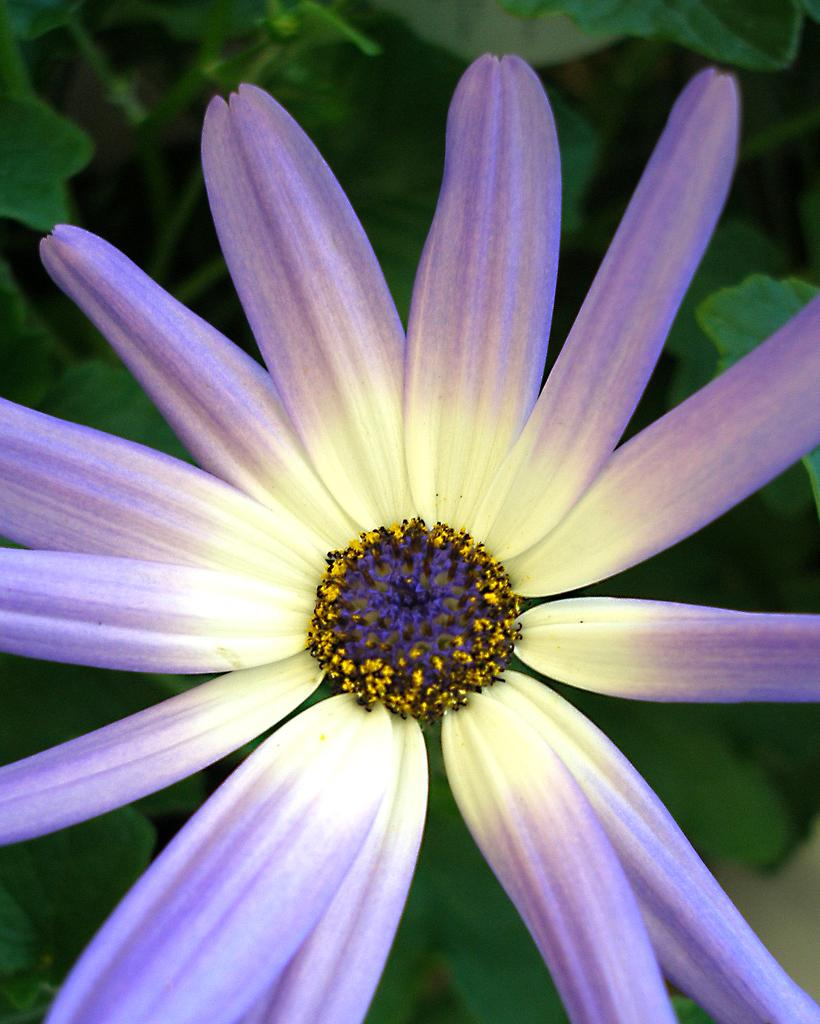What is the main subject in the center of the image? There is a flower in the center of the image. What can be seen in the background of the image? There are plants in the background of the image. What time is displayed on the watch in the image? There is no watch present in the image; it features a flower and plants. What type of plate is being offered to the flower in the image? There is no plate or offering to the flower in the image; it simply shows the flower and plants. 